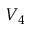Convert formula to latex. <formula><loc_0><loc_0><loc_500><loc_500>V _ { 4 }</formula> 